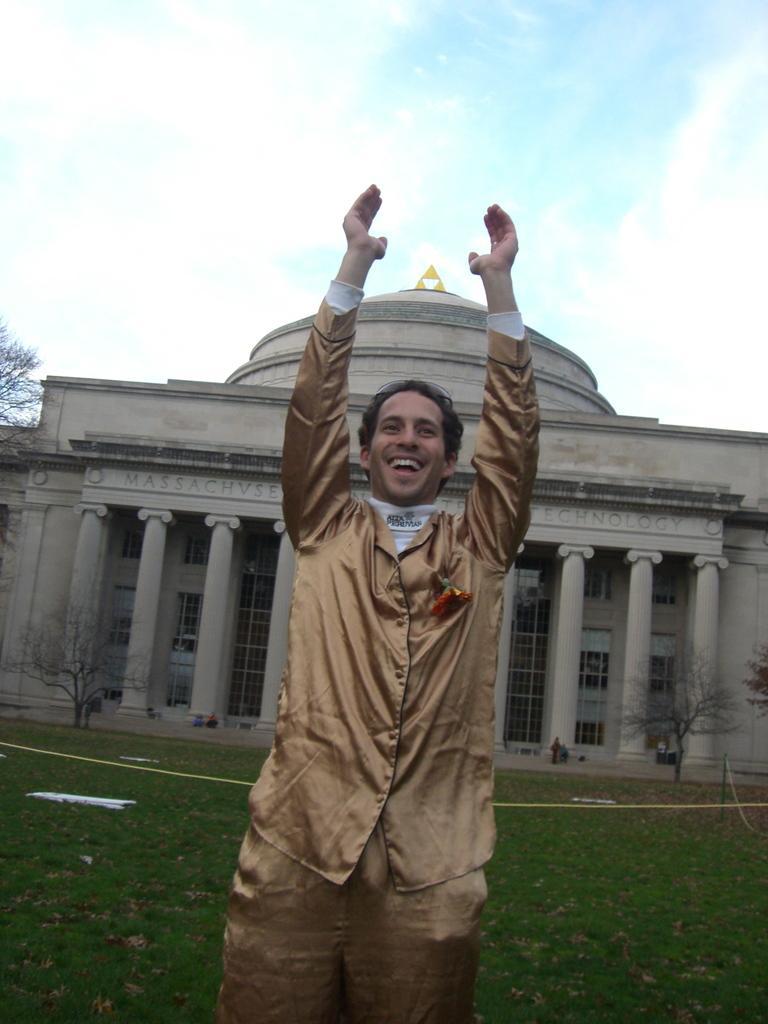In one or two sentences, can you explain what this image depicts? In this picture we can see a man and he is smiling and in the background we can see a building, trees, grass, people and sky with clouds. 